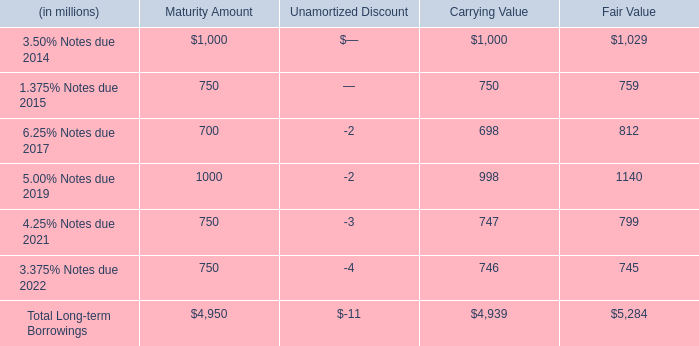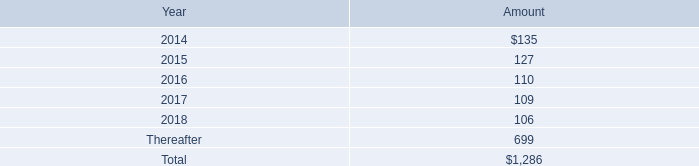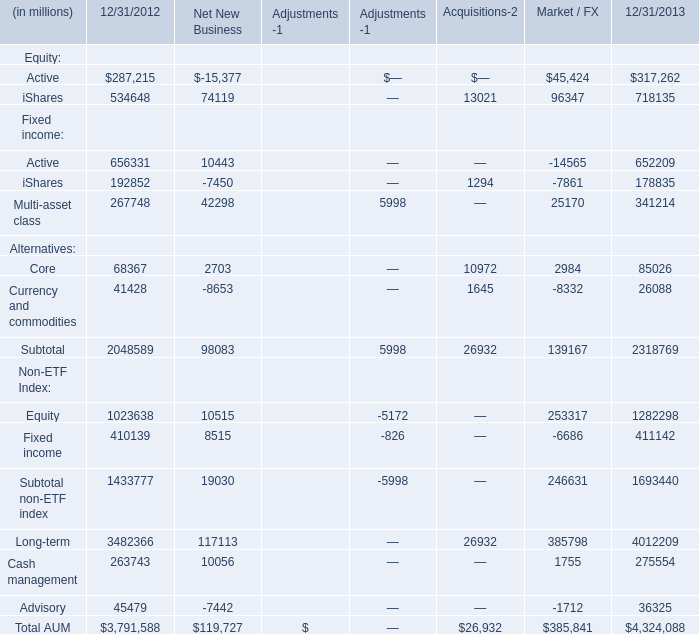how much higher is the fair value than carrying value ? in millions $ . 
Computations: (5284 - 4939)
Answer: 345.0. 